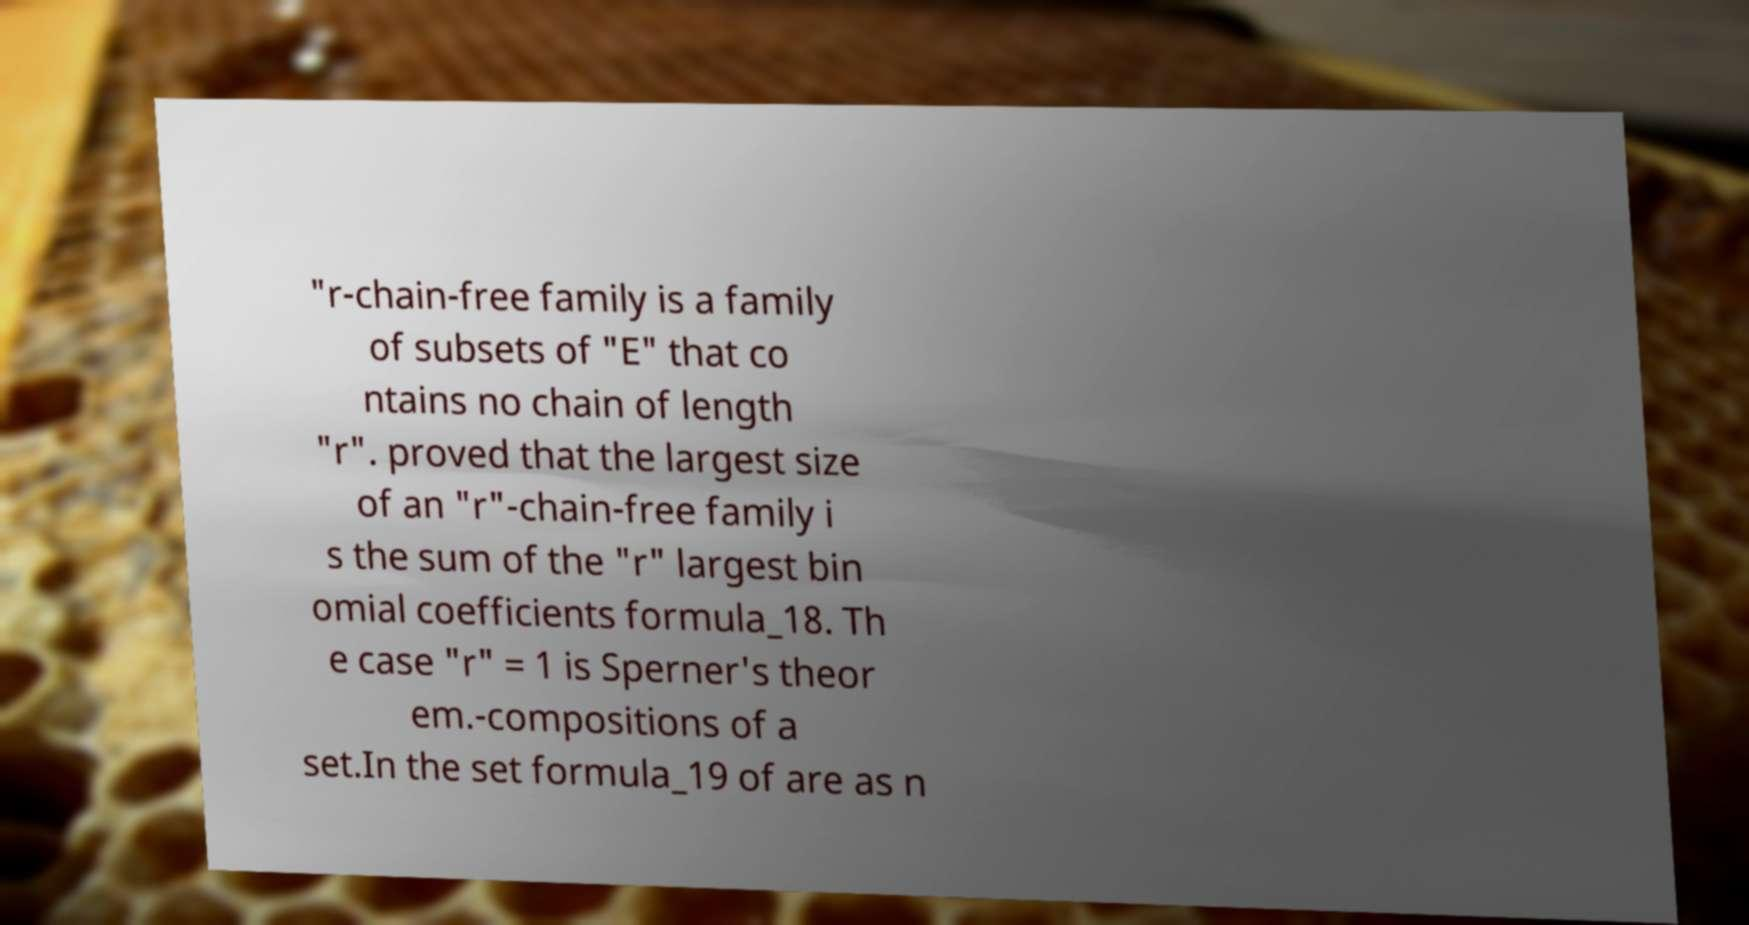Could you extract and type out the text from this image? "r-chain-free family is a family of subsets of "E" that co ntains no chain of length "r". proved that the largest size of an "r"-chain-free family i s the sum of the "r" largest bin omial coefficients formula_18. Th e case "r" = 1 is Sperner's theor em.-compositions of a set.In the set formula_19 of are as n 